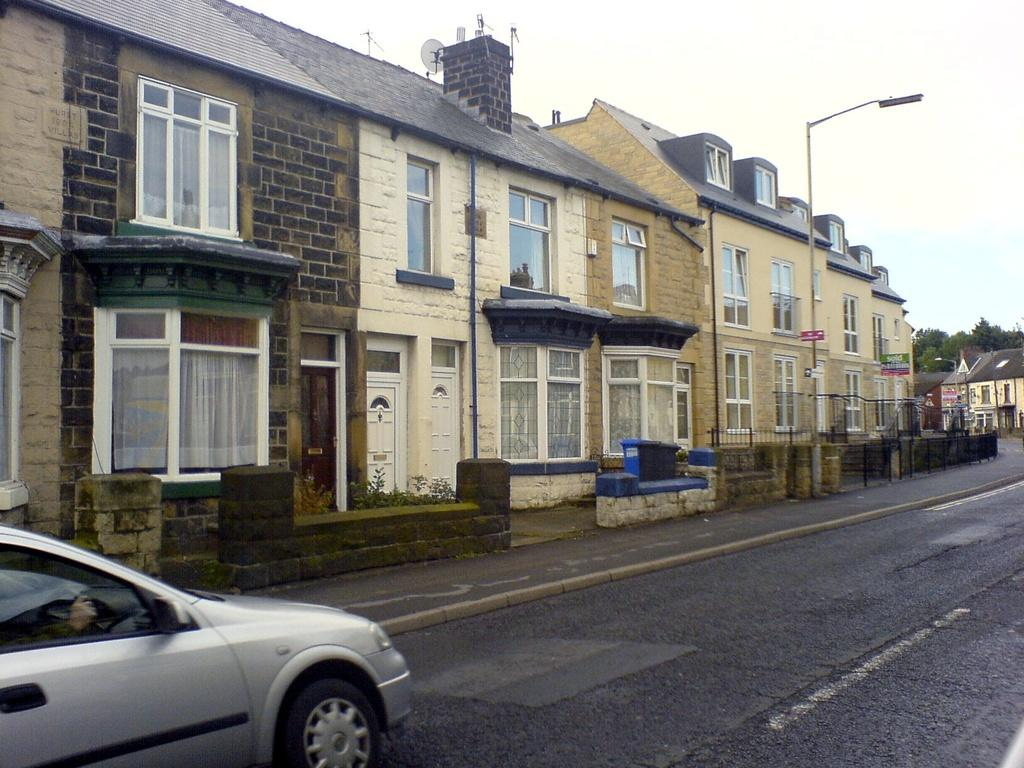What is the main subject of the image? There is a vehicle on the road in the image. What can be seen in the background of the image? There are buildings, trees, and the sky visible in the background of the image. Can you describe the unspecified objects in the background? Unfortunately, the provided facts do not specify the nature of these objects, so it is impossible to describe them. What time of day is it in the image, given that it is night? The provided facts do not mention the time of day, and there is no indication of nighttime in the image. 